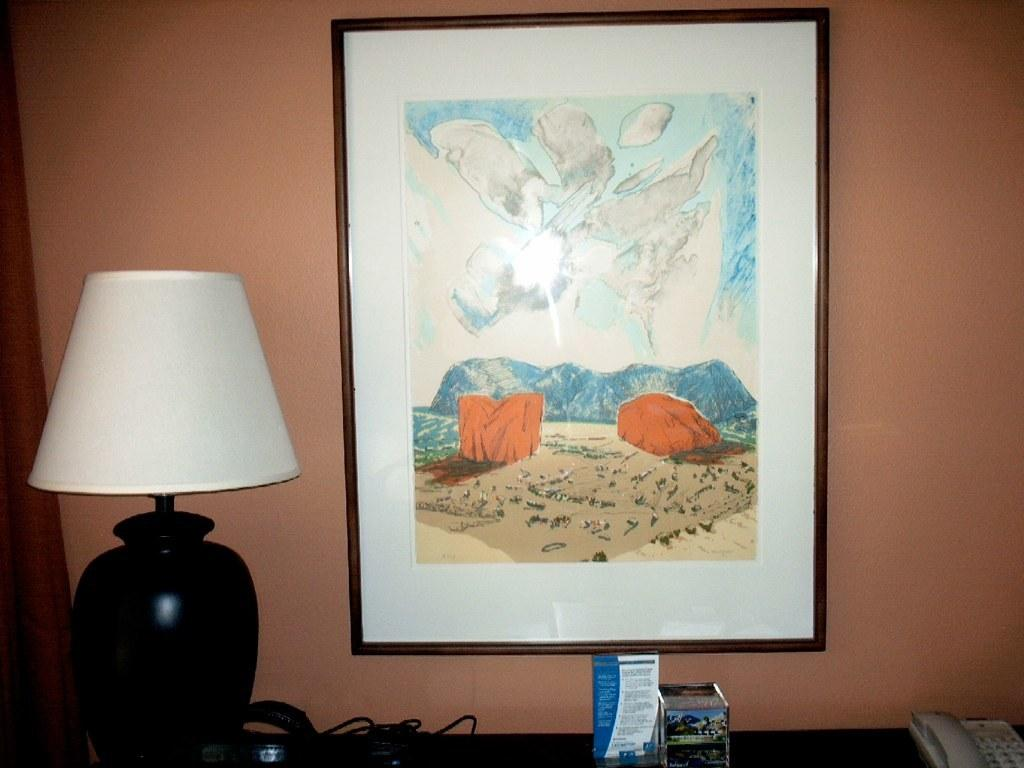What type of lighting fixture is present in the image? There is a light lamp in the image. What communication device can be seen in the image? There is a telephone in the image. What other objects are present on the table in the image? There are other objects on the table in the image, but their specific details are not mentioned in the facts. What is attached to the wall in the image? There is a photo attached to a wall in the image. What is depicted in the photo? The photo contains a painting of something, but the specific subject matter is not mentioned in the facts. How many apples are being used as a nerve channel in the image? There are no apples or nerve channels present in the image. What type of channel is depicted in the painting within the photo? The specific subject matter of the painting within the photo is not mentioned in the facts, so it cannot be determined if a channel is depicted. 